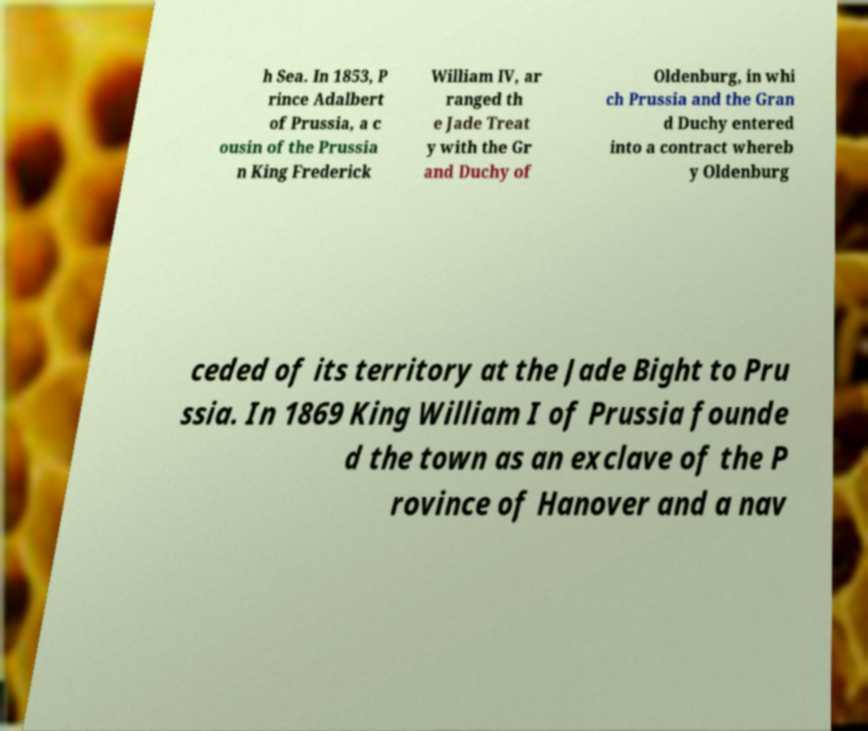Can you accurately transcribe the text from the provided image for me? h Sea. In 1853, P rince Adalbert of Prussia, a c ousin of the Prussia n King Frederick William IV, ar ranged th e Jade Treat y with the Gr and Duchy of Oldenburg, in whi ch Prussia and the Gran d Duchy entered into a contract whereb y Oldenburg ceded of its territory at the Jade Bight to Pru ssia. In 1869 King William I of Prussia founde d the town as an exclave of the P rovince of Hanover and a nav 